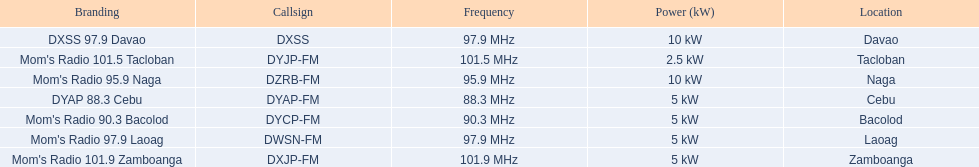What is the radio with the least about of mhz? DYAP 88.3 Cebu. 